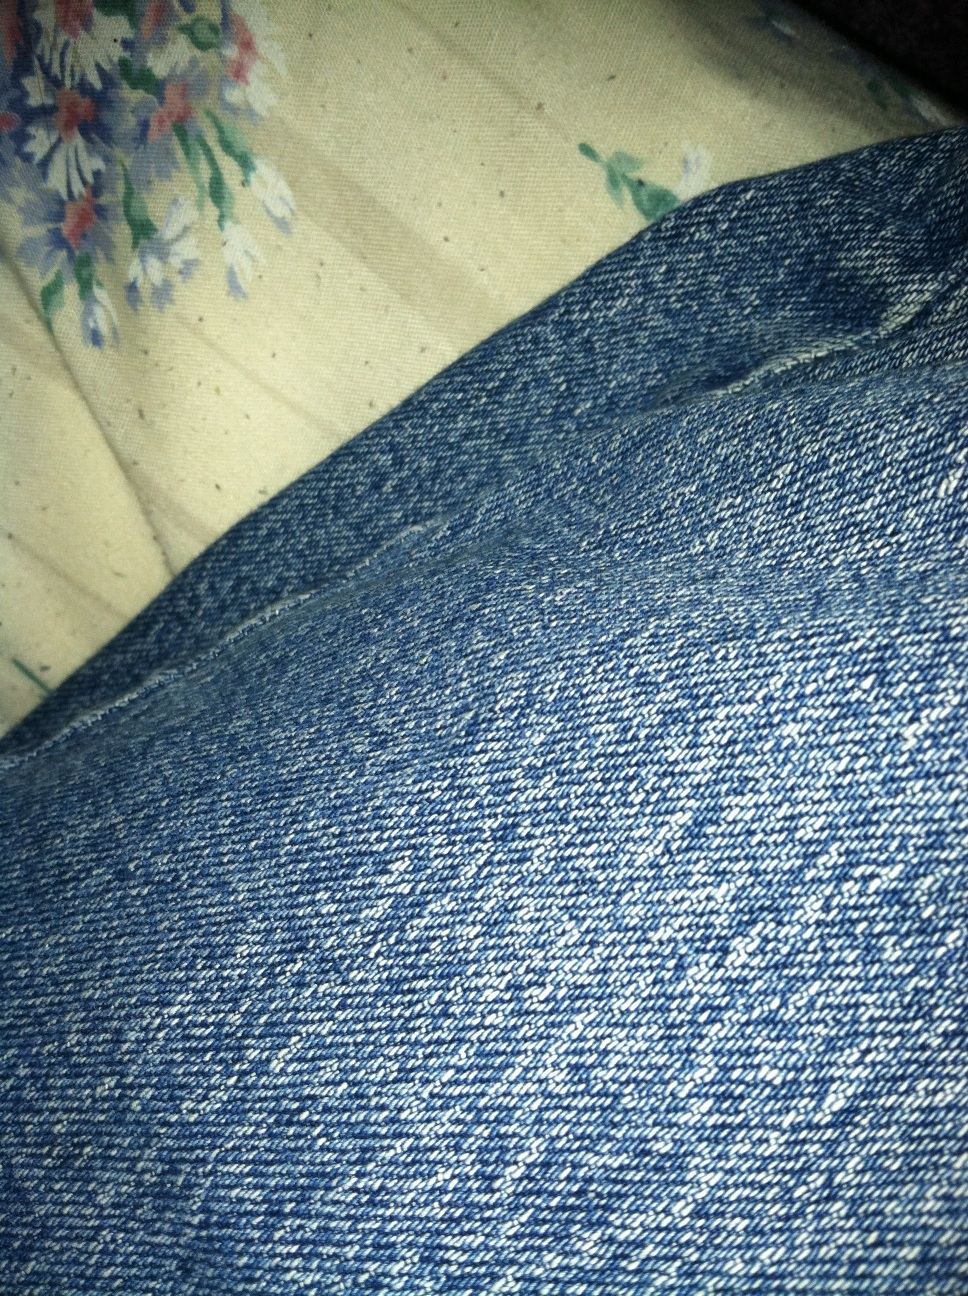How might one style these blue jeans for a casual day out? A pair of blue jeans like these can be styled in many versatile ways for a casual day out. You could pair them with a classic white t-shirt and some comfortable sneakers for a timeless, effortless look. Add a light jacket or a flannel shirt for an extra layer if it's chilly. Accessories such as a simple belt, a casual watch, and a pair of sunglasses can elevate the outfit subtly. Blue jeans are incredibly versatile and can be dressed up or down based on the accompanying pieces you choose. 